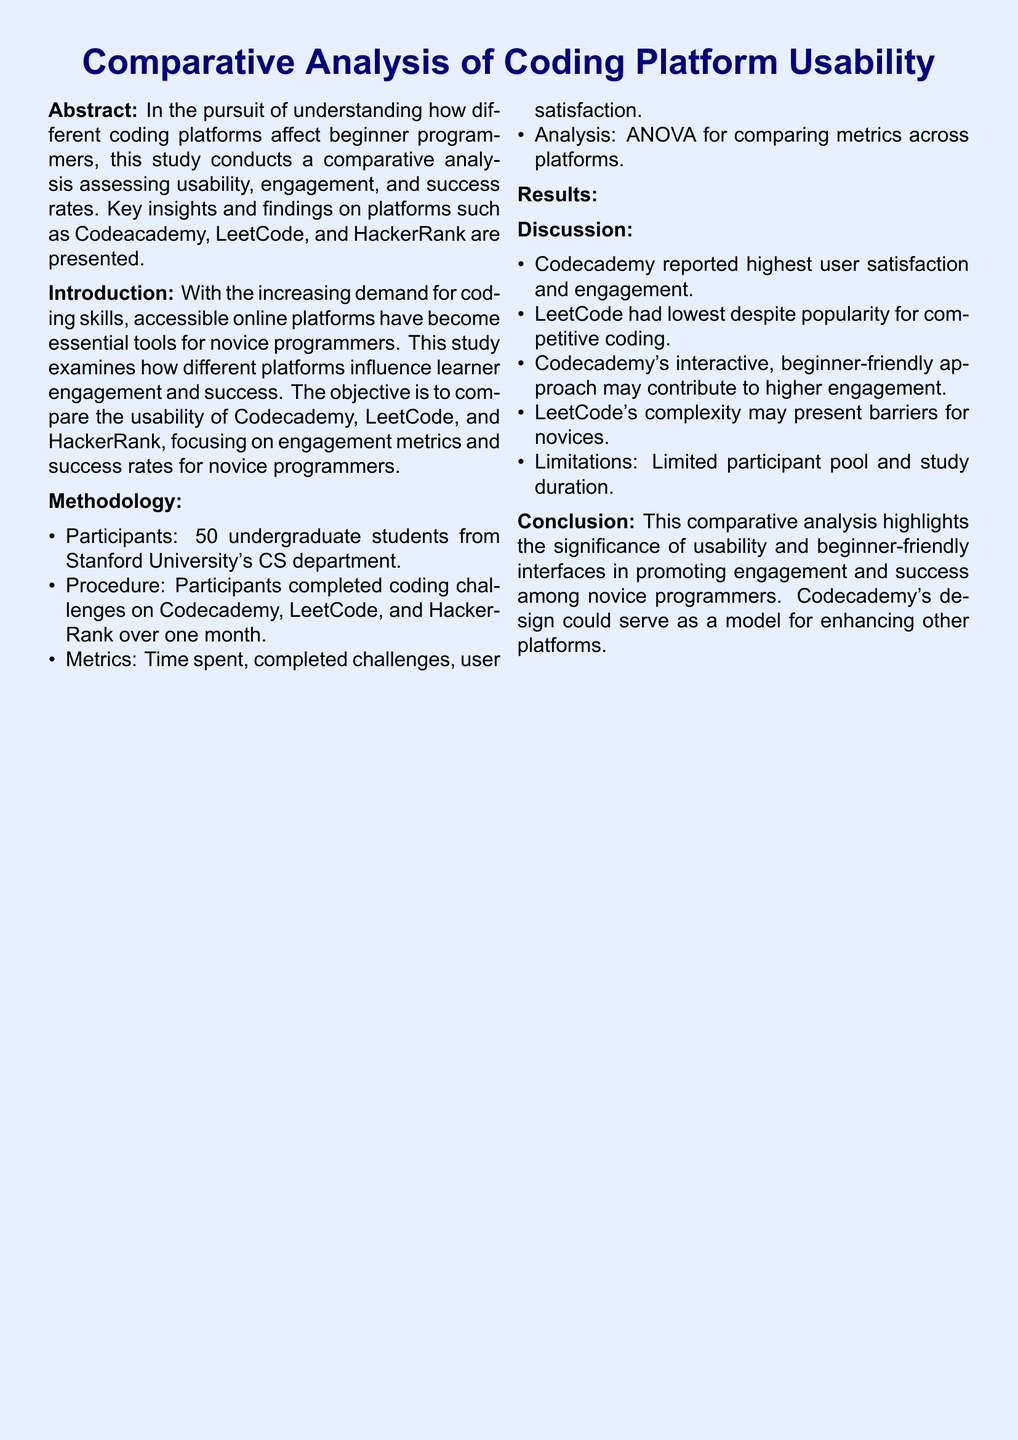What is the main focus of the study? The main focus of the study is to compare the usability, engagement, and success rates of different coding platforms for novice programmers.
Answer: Usability, engagement, and success rates Who were the participants of the study? The participants of the study were undergraduate students from Stanford University's CS department.
Answer: 50 undergraduate students Which platform had the highest average satisfaction? The platform with the highest average satisfaction was Codecademy.
Answer: Codecademy What was the completion rate for LeetCode? The completion rate for LeetCode was 50%.
Answer: 50% What does the study highlight as significant for novice programmers? The study highlights the significance of usability and beginner-friendly interfaces for promoting engagement and success.
Answer: Usability and beginner-friendly interfaces What statistical method was used to analyze the data? The statistical method used to analyze the data was ANOVA.
Answer: ANOVA Which platform reported the highest time spent per day? The platform that reported the highest time spent per day was Codecademy.
Answer: Codecademy What is a limitation mentioned in the discussion? A limitation mentioned in the discussion is the limited participant pool and study duration.
Answer: Limited participant pool and study duration 